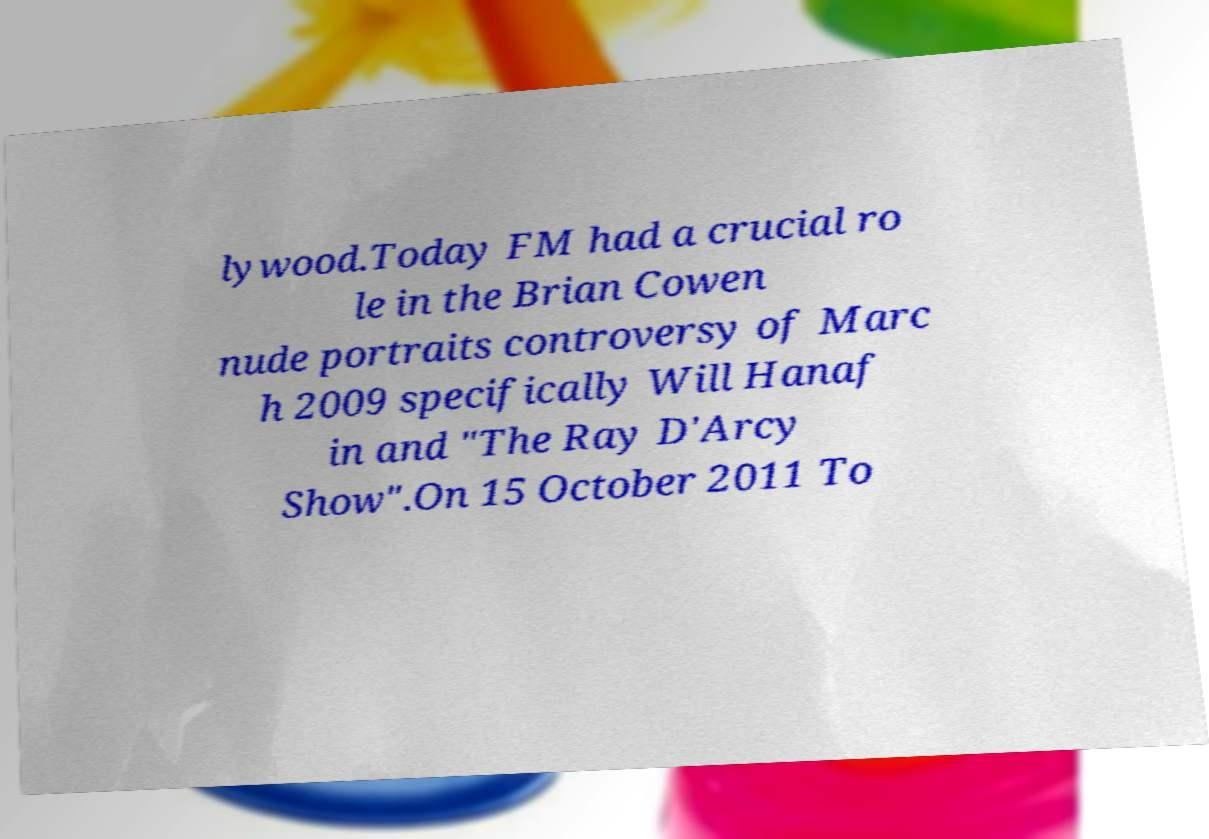Could you extract and type out the text from this image? lywood.Today FM had a crucial ro le in the Brian Cowen nude portraits controversy of Marc h 2009 specifically Will Hanaf in and "The Ray D'Arcy Show".On 15 October 2011 To 